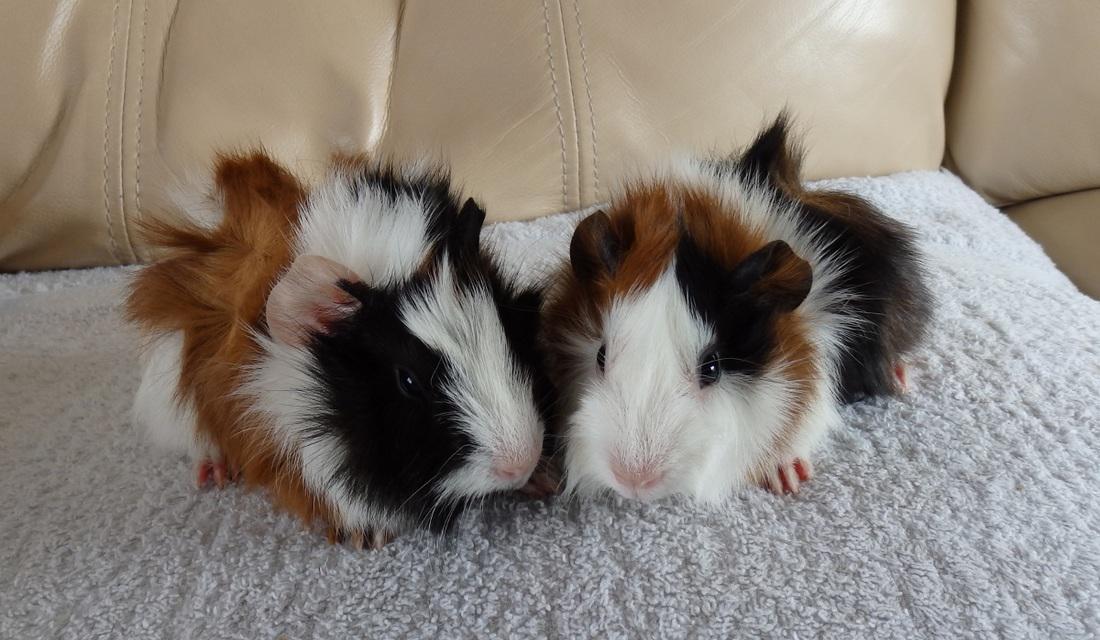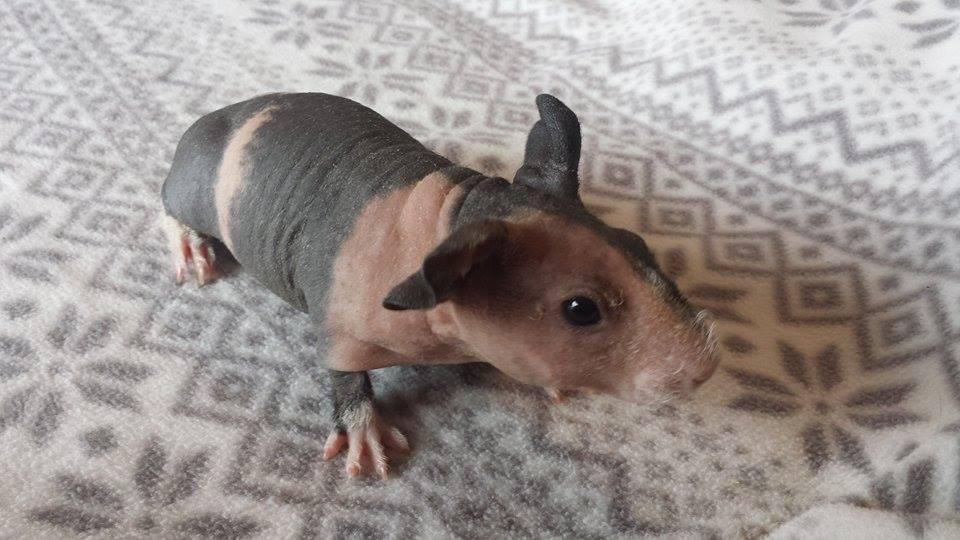The first image is the image on the left, the second image is the image on the right. Considering the images on both sides, is "There are exactly three rodents in the image on the left." valid? Answer yes or no. No. The first image is the image on the left, the second image is the image on the right. Evaluate the accuracy of this statement regarding the images: "There are no more than five animals". Is it true? Answer yes or no. Yes. 